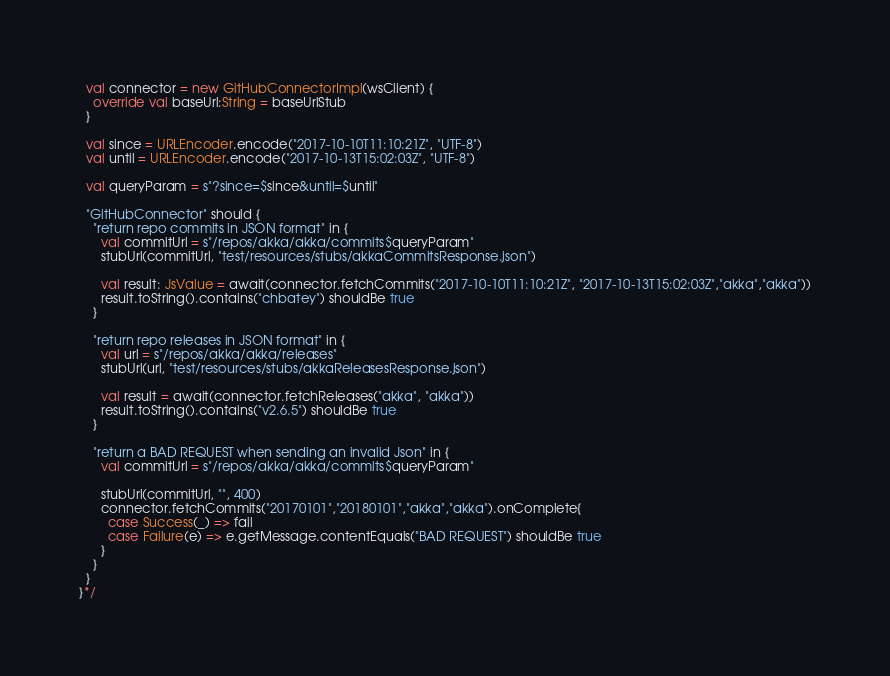<code> <loc_0><loc_0><loc_500><loc_500><_Scala_>  val connector = new GitHubConnectorImpl(wsClient) {
    override val baseUrl:String = baseUrlStub
  }

  val since = URLEncoder.encode("2017-10-10T11:10:21Z", "UTF-8")
  val until = URLEncoder.encode("2017-10-13T15:02:03Z", "UTF-8")

  val queryParam = s"?since=$since&until=$until"

  "GitHubConnector" should {
    "return repo commits in JSON format" in {
      val commitUrl = s"/repos/akka/akka/commits$queryParam"
      stubUrl(commitUrl, "test/resources/stubs/akkaCommitsResponse.json")

      val result: JsValue = await(connector.fetchCommits("2017-10-10T11:10:21Z", "2017-10-13T15:02:03Z","akka","akka"))
      result.toString().contains("chbatey") shouldBe true
    }

    "return repo releases in JSON format" in {
      val url = s"/repos/akka/akka/releases"
      stubUrl(url, "test/resources/stubs/akkaReleasesResponse.json")

      val result = await(connector.fetchReleases("akka", "akka"))
      result.toString().contains("v2.6.5") shouldBe true
    }

    "return a BAD REQUEST when sending an invalid Json" in {
      val commitUrl = s"/repos/akka/akka/commits$queryParam"

      stubUrl(commitUrl, "", 400)
      connector.fetchCommits("20170101","20180101","akka","akka").onComplete{
        case Success(_) => fail
        case Failure(e) => e.getMessage.contentEquals("BAD REQUEST") shouldBe true
      }
    }
  }
}*/
</code> 